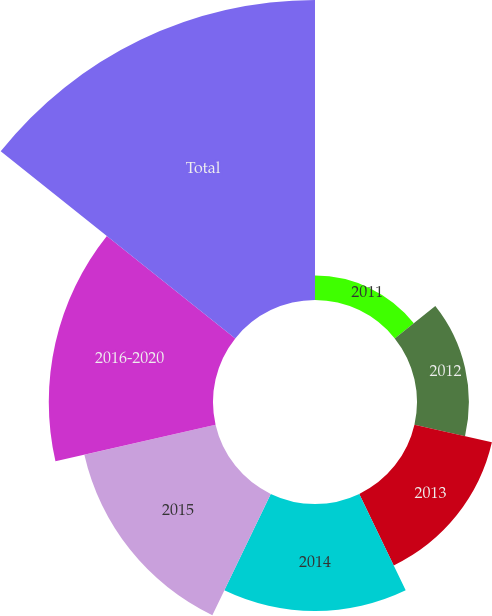<chart> <loc_0><loc_0><loc_500><loc_500><pie_chart><fcel>2011<fcel>2012<fcel>2013<fcel>2014<fcel>2015<fcel>2016-2020<fcel>Total<nl><fcel>2.83%<fcel>6.02%<fcel>9.22%<fcel>12.42%<fcel>15.62%<fcel>19.06%<fcel>34.82%<nl></chart> 